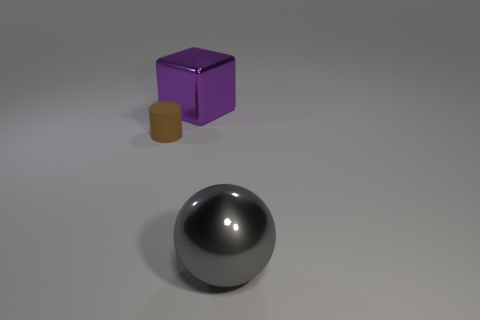Add 3 purple objects. How many objects exist? 6 Subtract all spheres. How many objects are left? 2 Subtract 1 brown cylinders. How many objects are left? 2 Subtract all purple spheres. Subtract all cyan blocks. How many spheres are left? 1 Subtract all tiny red metallic blocks. Subtract all big balls. How many objects are left? 2 Add 2 big gray things. How many big gray things are left? 3 Add 3 matte things. How many matte things exist? 4 